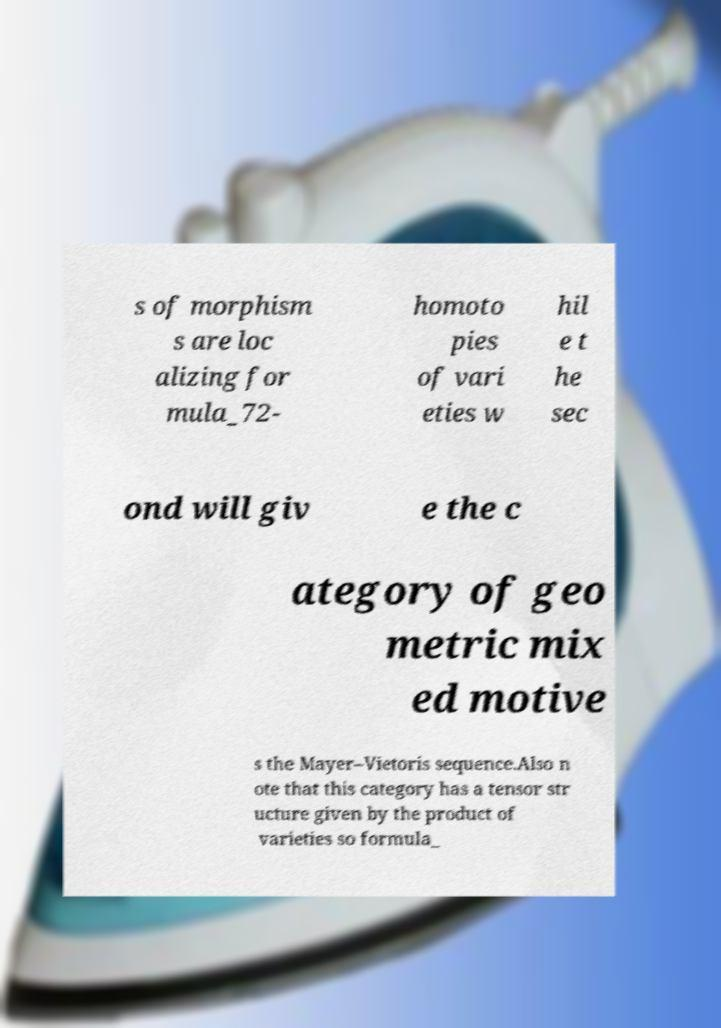Please identify and transcribe the text found in this image. s of morphism s are loc alizing for mula_72- homoto pies of vari eties w hil e t he sec ond will giv e the c ategory of geo metric mix ed motive s the Mayer–Vietoris sequence.Also n ote that this category has a tensor str ucture given by the product of varieties so formula_ 